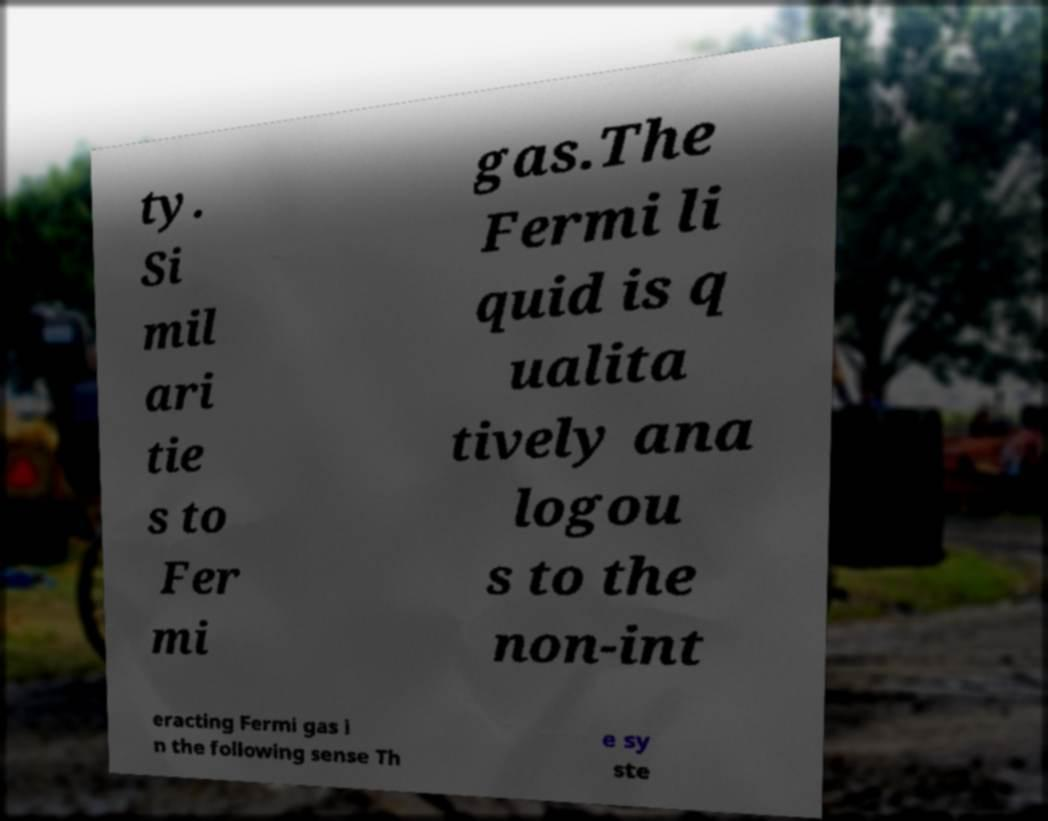For documentation purposes, I need the text within this image transcribed. Could you provide that? ty. Si mil ari tie s to Fer mi gas.The Fermi li quid is q ualita tively ana logou s to the non-int eracting Fermi gas i n the following sense Th e sy ste 